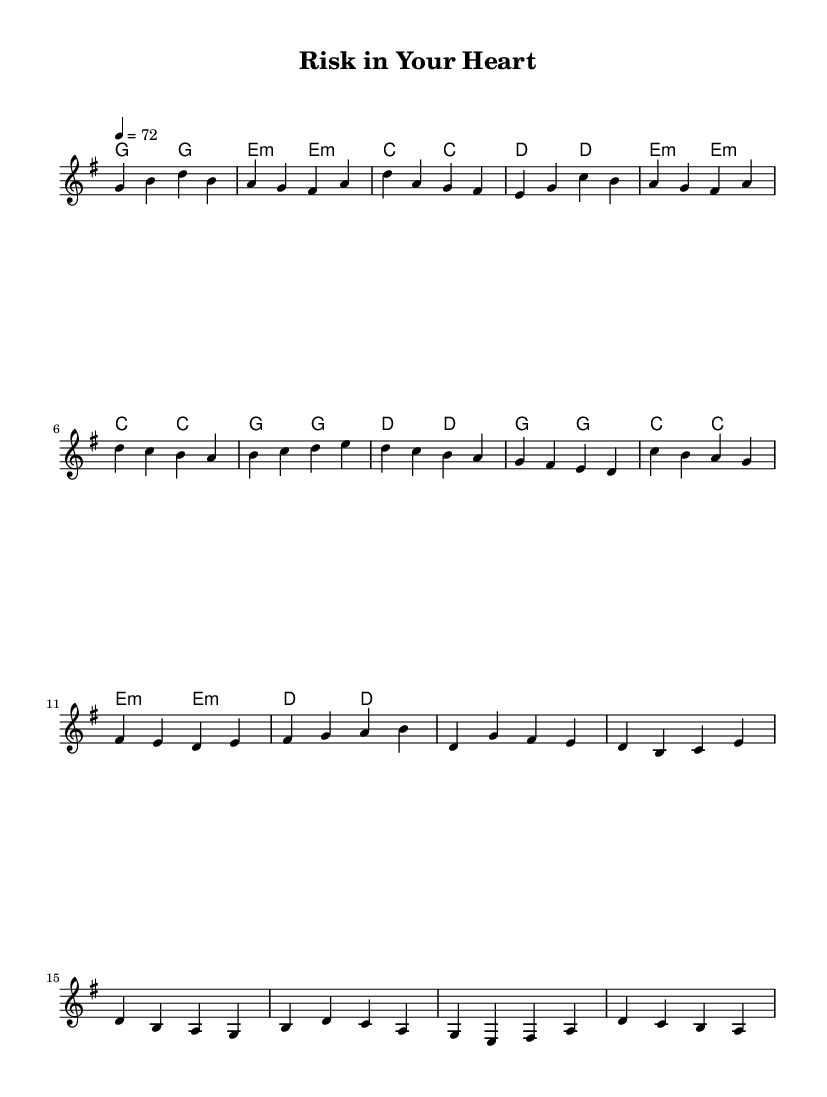What is the key signature of this music? The key signature is G major, which has one sharp (F#).
Answer: G major What is the time signature of this music? The time signature is 4/4, indicating four beats in a measure.
Answer: 4/4 What is the tempo marking for this piece? The tempo marking is indicated as 72 beats per minute.
Answer: 72 How many measures are in the verse section? The verse section includes 6 measures, as counted in the provided melody.
Answer: 6 How does the pre-chorus connect to the chorus musically? The pre-chorus transitions directly into the chorus, as the last lyric of the pre-chorus leads into the chorus without a break, showcasing a seamless flow that is characteristic of K-Pop.
Answer: Seamless transition What emotion is conveyed in the chorus based on the lyrics? The chorus expresses a sense of emotional risk and the value of love, highlighting how it cannot be quantified, which conveys vulnerability and importance.
Answer: Vulnerability What is the structure of the song? The structure includes a verse, a pre-chorus, and a chorus, which is typical for K-Pop ballads focusing on narrative flow and emotional buildup.
Answer: Verse, Pre-Chorus, Chorus 